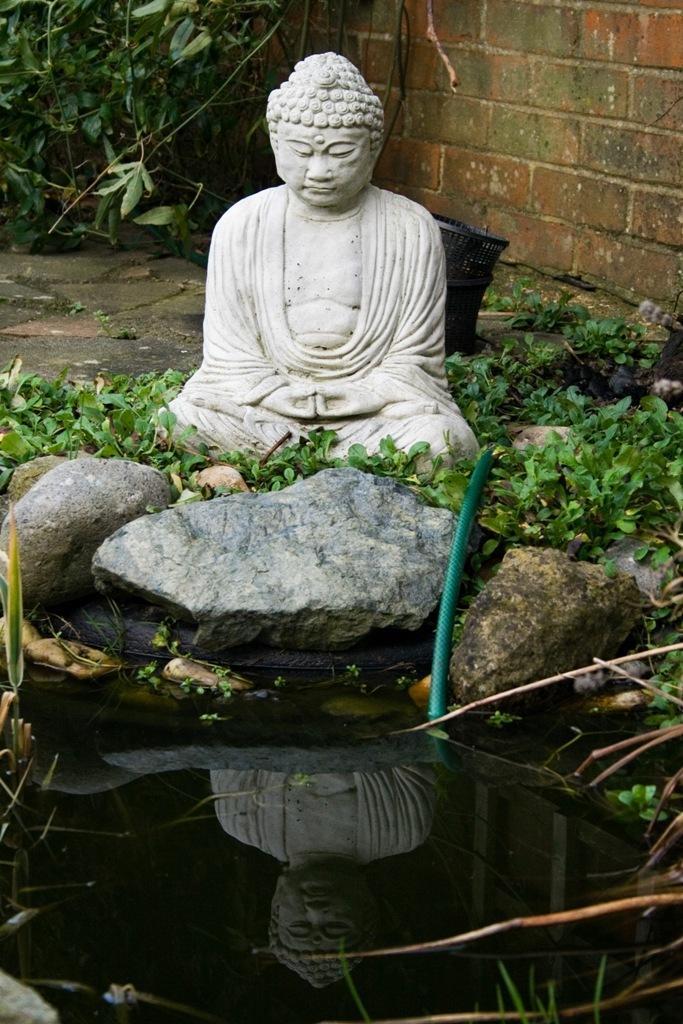Please provide a concise description of this image. In this image we can see a statue on the surface. We can also see some stones, a pipe, water, containers and a wall. 